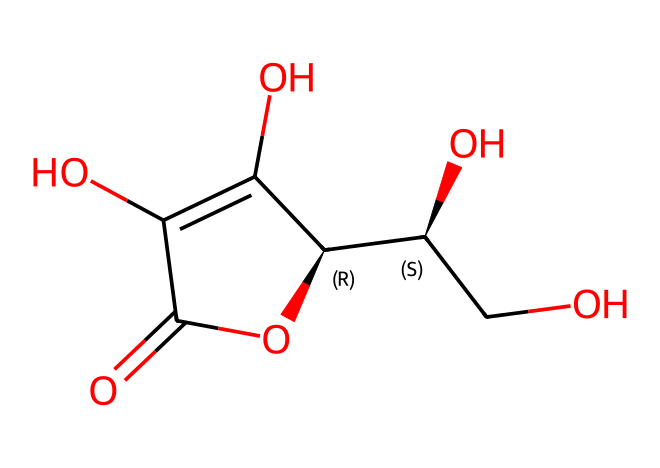What is the molecular formula of ascorbic acid? Ascorbic acid's structure indicates the presence of specific atoms, including carbon, hydrogen, and oxygen. Counting from the structure, we find it consists of six carbon atoms, eight hydrogen atoms, and six oxygen atoms, leading to the molecular formula C6H8O6.
Answer: C6H8O6 How many hydroxyl (-OH) groups are present in ascorbic acid? The OH groups are part of the structure visible in the SMILES representation. In total, there are four oxygen atoms that appear as -OH groups when investigating the chemical thoroughly.
Answer: four What functional group is predominant in ascorbic acid? A close examination of the structure shows multiple hydroxyl groups, which is a characteristic of alcohols. Additionally, the presence of a carbonyl (C=O) suggests that it is also a type of carbohydrate. Therefore, the predominant functional group here is hydroxyl.
Answer: hydroxyl What type of compound is ascorbic acid classified as? Given its structure and the presence of both hydroxyl and carbonyl groups, ascorbic acid falls under the category of vitamins. More specifically, since it acts as an antioxidant, it is categorized as a food additive with vitamin properties.
Answer: vitamin How does the arrangement of atoms affect the antioxidant properties of ascorbic acid? The specific arrangement and the presence of active hydroxyl groups in ascorbic acid allow it to donate electrons, acting effectively as an antioxidant. The spatial geometry also determines how efficiently it can interact with free radicals.
Answer: antioxidant What is the key role of ascorbic acid in fruit juices? Ascorbic acid's primary role is its function as an antioxidant, helping to prevent oxidation and spoilage in fruit juices. This ability to neutralize free radicals keeps the juice fresher and retains vitamin content.
Answer: antioxidant 